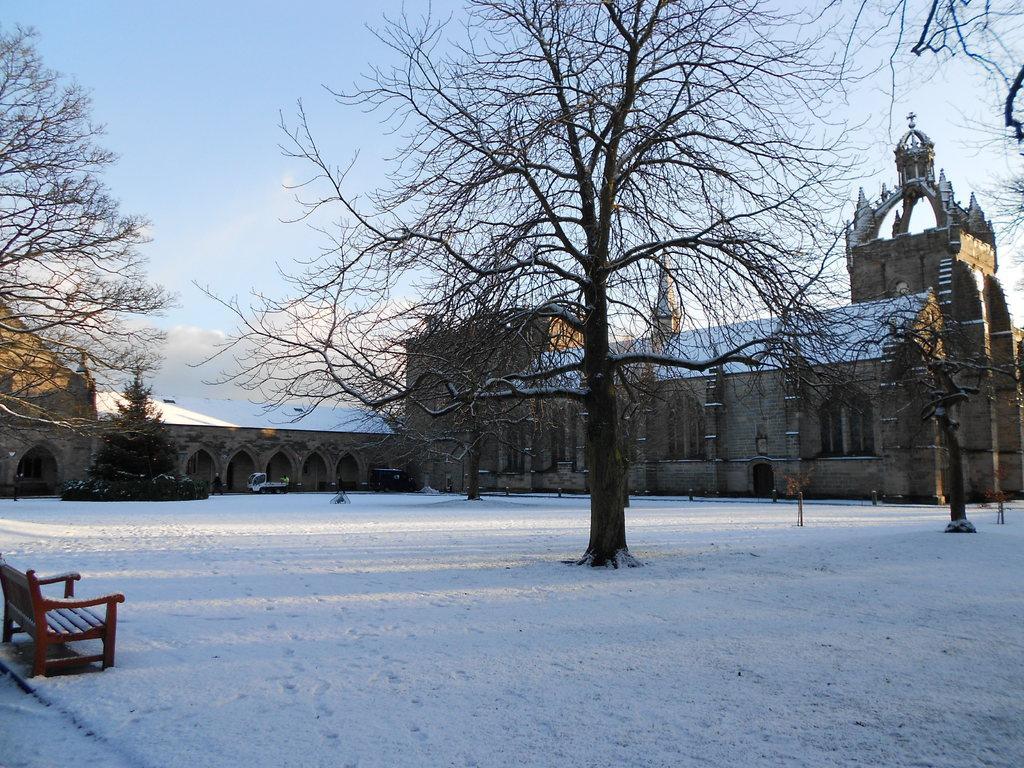Please provide a concise description of this image. In the picture there is a compartment, it is very large and around that there are few dry trees and there is a lot of snow around the trees and on the left side there is a bench. 